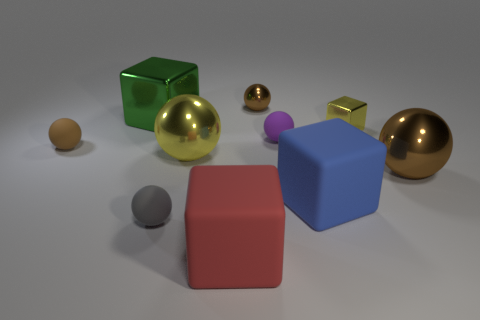How many brown spheres must be subtracted to get 1 brown spheres? 2 Subtract all large blocks. How many blocks are left? 1 Subtract all balls. How many objects are left? 4 Subtract 3 balls. How many balls are left? 3 Subtract all blue blocks. How many blocks are left? 3 Subtract all cyan cubes. How many brown balls are left? 3 Add 6 small spheres. How many small spheres exist? 10 Subtract 0 yellow cylinders. How many objects are left? 10 Subtract all green balls. Subtract all yellow cylinders. How many balls are left? 6 Subtract all large purple metallic spheres. Subtract all big objects. How many objects are left? 5 